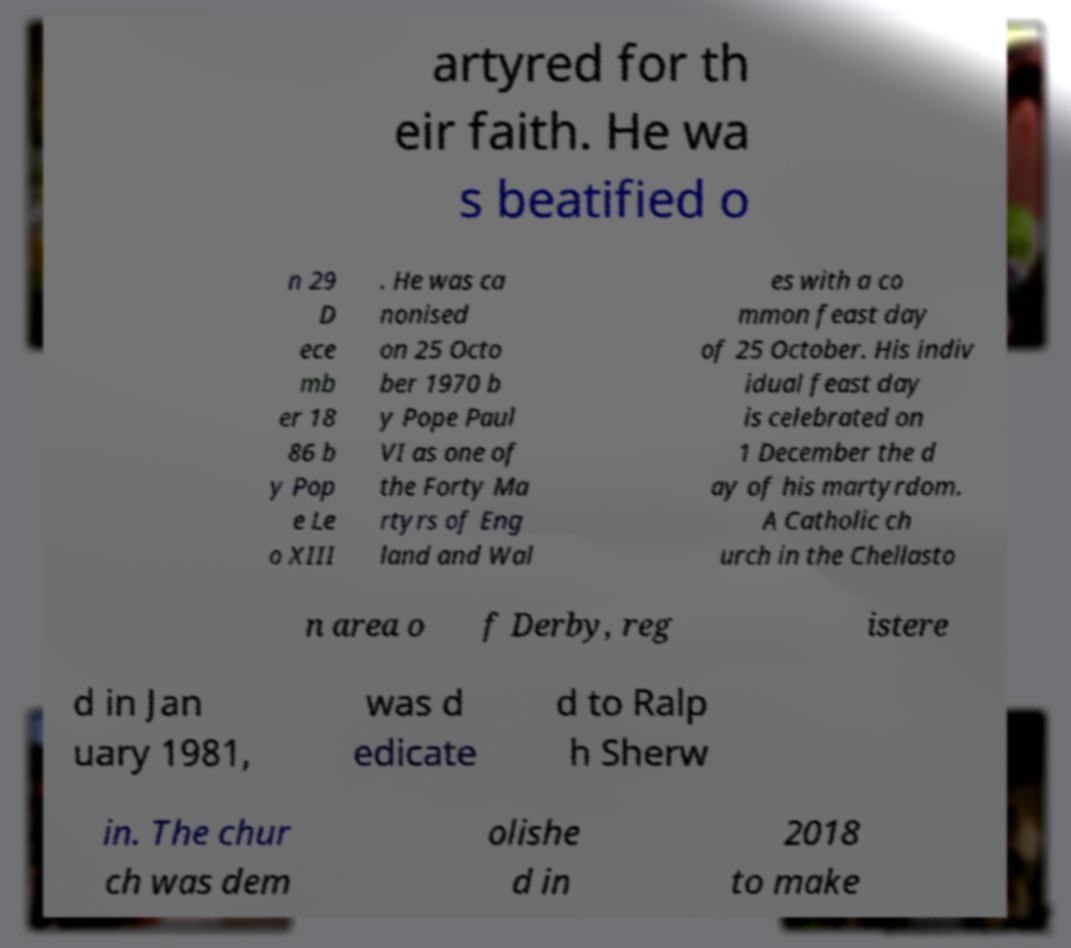Can you read and provide the text displayed in the image?This photo seems to have some interesting text. Can you extract and type it out for me? artyred for th eir faith. He wa s beatified o n 29 D ece mb er 18 86 b y Pop e Le o XIII . He was ca nonised on 25 Octo ber 1970 b y Pope Paul VI as one of the Forty Ma rtyrs of Eng land and Wal es with a co mmon feast day of 25 October. His indiv idual feast day is celebrated on 1 December the d ay of his martyrdom. A Catholic ch urch in the Chellasto n area o f Derby, reg istere d in Jan uary 1981, was d edicate d to Ralp h Sherw in. The chur ch was dem olishe d in 2018 to make 